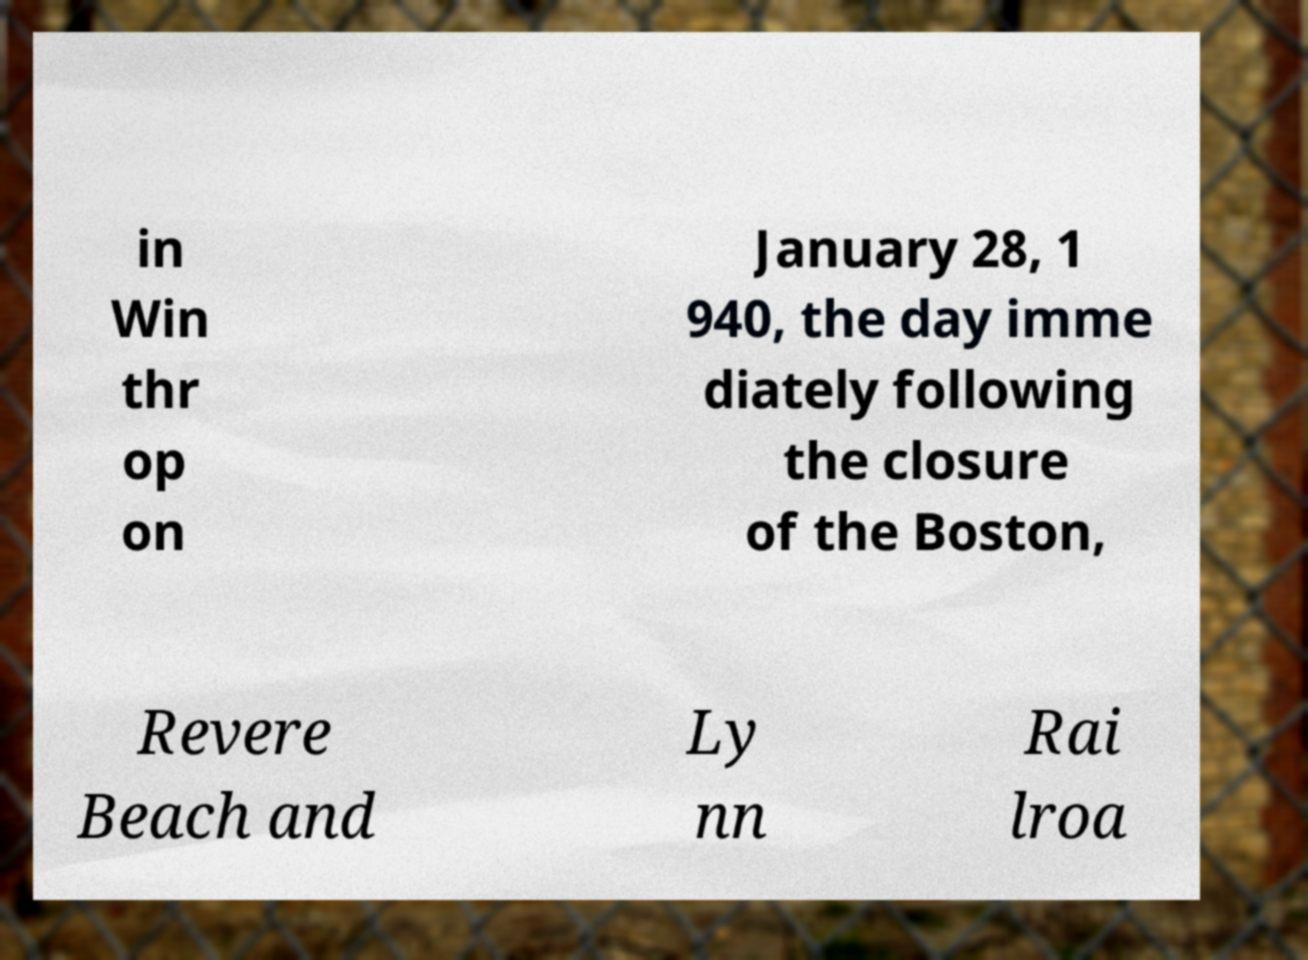Can you read and provide the text displayed in the image?This photo seems to have some interesting text. Can you extract and type it out for me? in Win thr op on January 28, 1 940, the day imme diately following the closure of the Boston, Revere Beach and Ly nn Rai lroa 